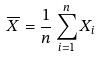<formula> <loc_0><loc_0><loc_500><loc_500>\overline { X } = \frac { 1 } { n } \sum _ { i = 1 } ^ { n } X _ { i }</formula> 